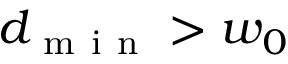<formula> <loc_0><loc_0><loc_500><loc_500>d _ { m i n } > w _ { 0 }</formula> 